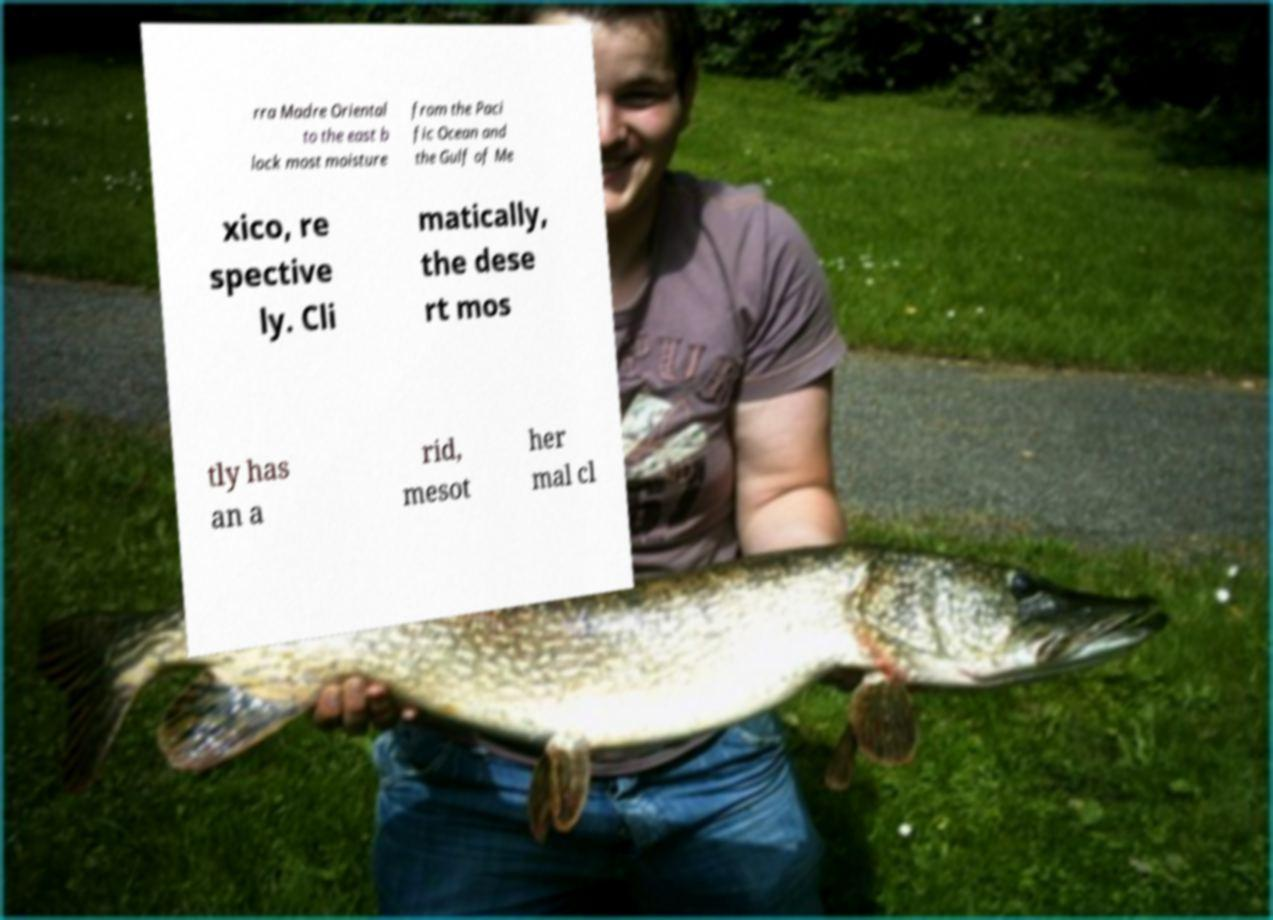For documentation purposes, I need the text within this image transcribed. Could you provide that? rra Madre Oriental to the east b lock most moisture from the Paci fic Ocean and the Gulf of Me xico, re spective ly. Cli matically, the dese rt mos tly has an a rid, mesot her mal cl 